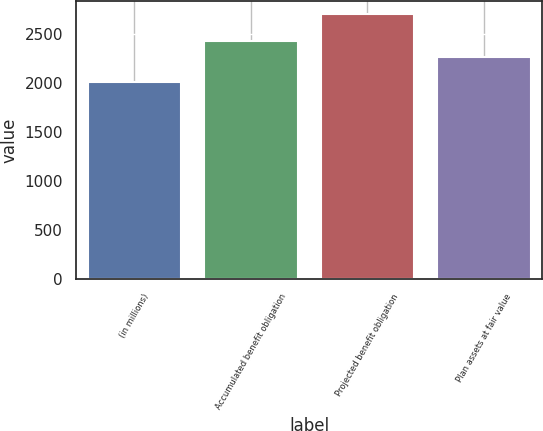Convert chart. <chart><loc_0><loc_0><loc_500><loc_500><bar_chart><fcel>(in millions)<fcel>Accumulated benefit obligation<fcel>Projected benefit obligation<fcel>Plan assets at fair value<nl><fcel>2014<fcel>2426<fcel>2703<fcel>2268<nl></chart> 